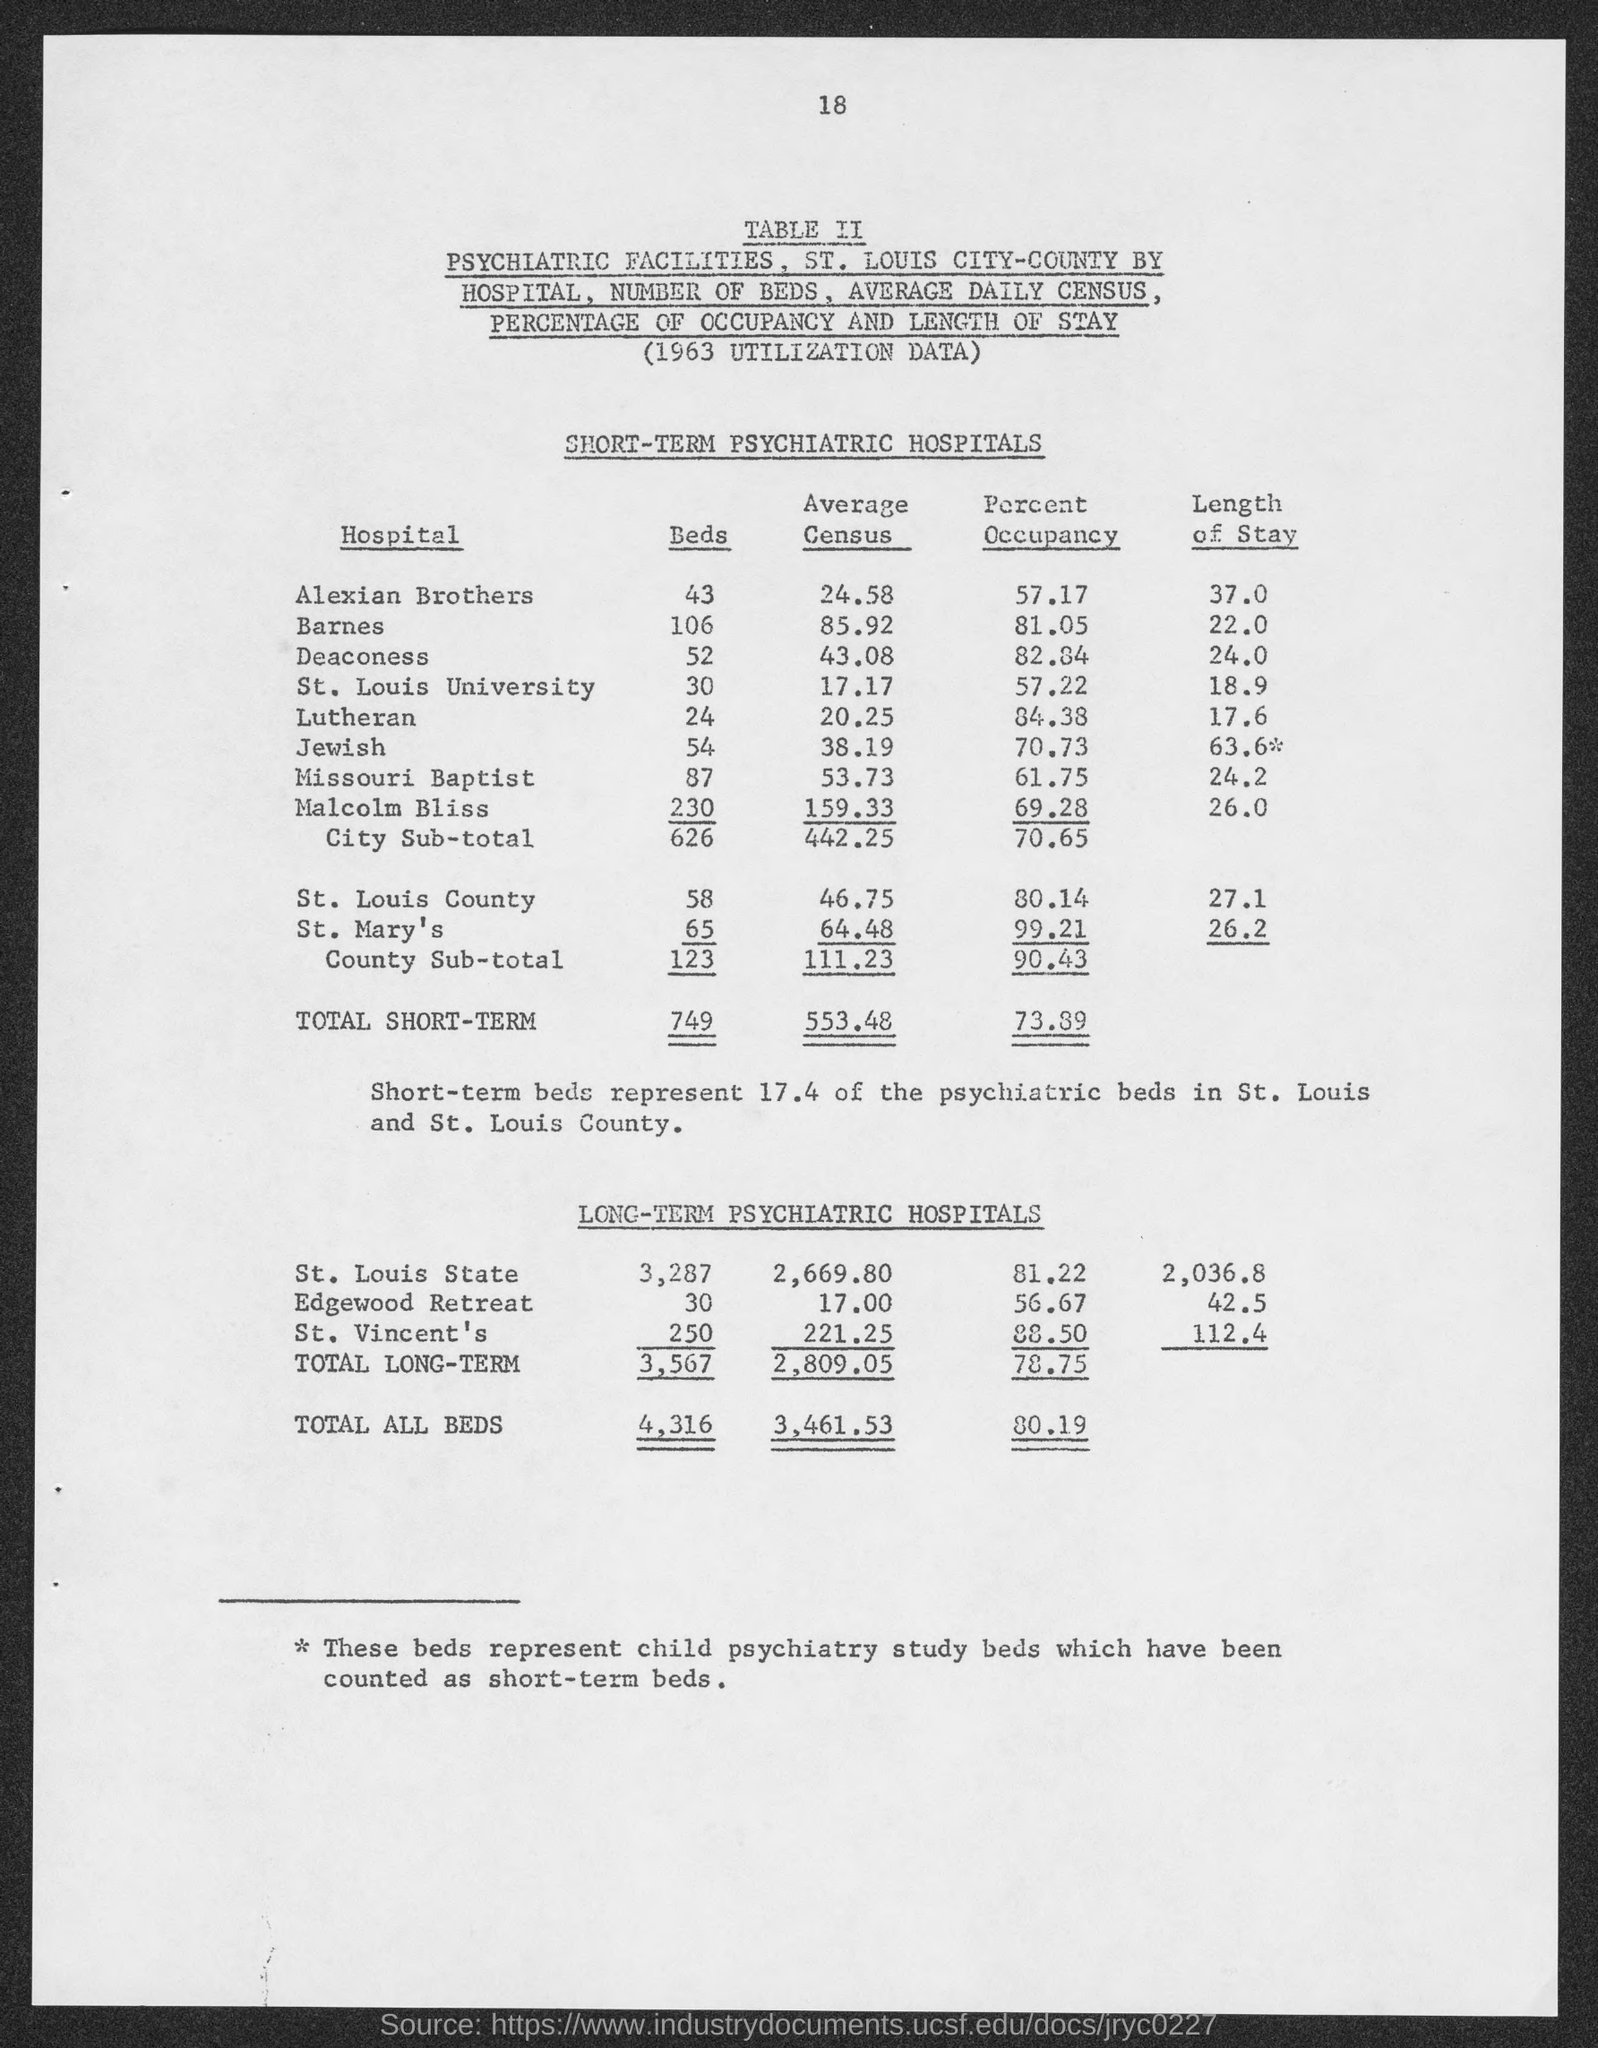List a handful of essential elements in this visual. Barnes Hospital has an average census of 85.92 patients. The total number of beds in Long-term care facilities is 3,567. The total number of beds is 4,316. The average census of Alexian Brothers Hospital is 24.58 patients. As of the current date, the total number of beds in the Short-Term category is 749. 